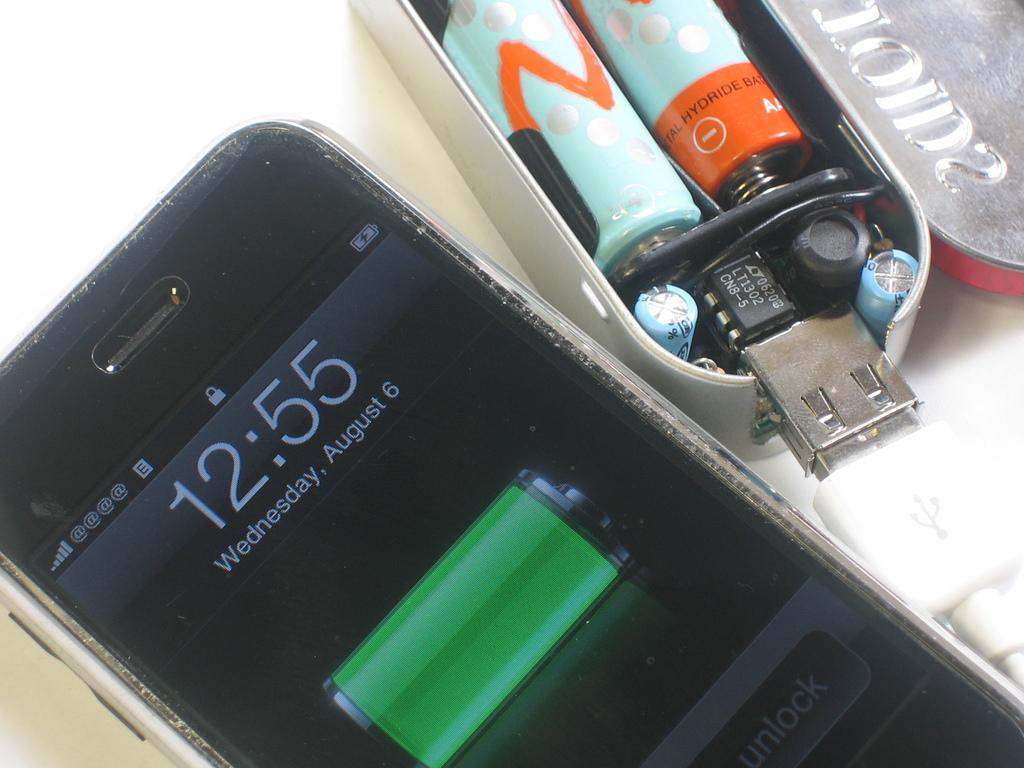What time is on the phone?
Offer a very short reply. 12:55. 